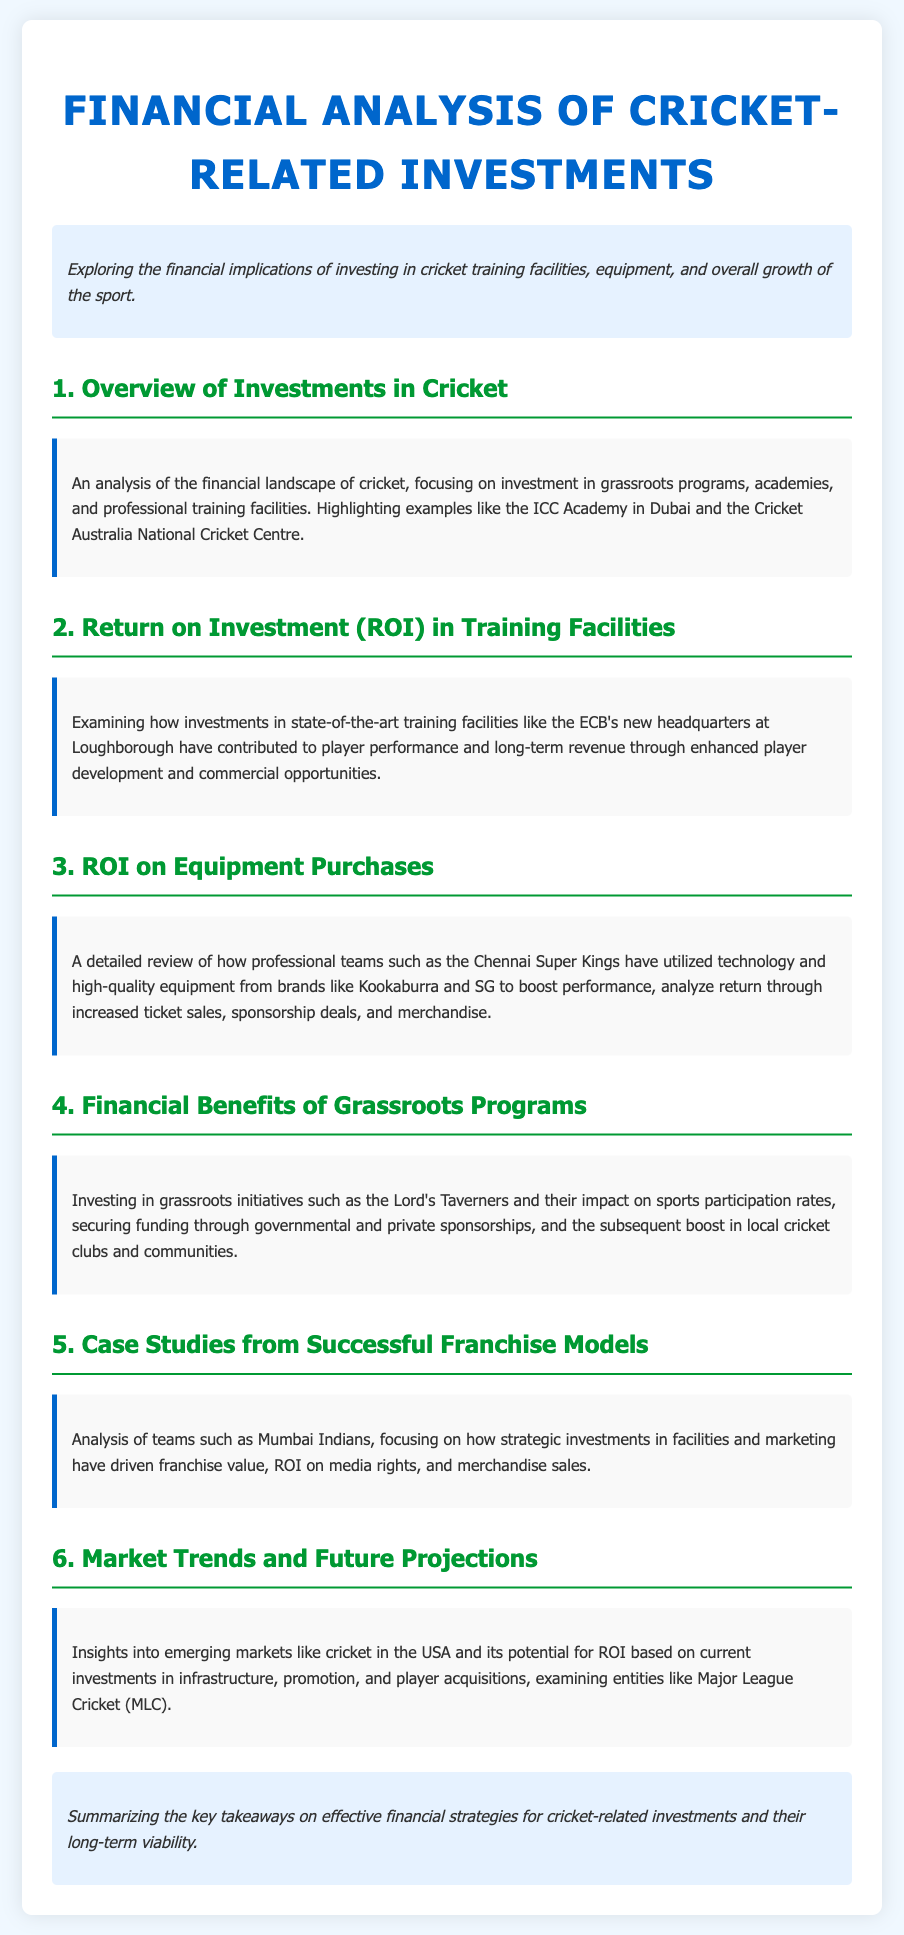What is the focus of the financial analysis? The focus is on investing in cricket training facilities, equipment, and overall growth of the sport.
Answer: Investing in cricket training facilities What does ROI stand for? ROI stands for Return on Investment, examining the profitability of investments made.
Answer: Return on Investment Which cricket academy is mentioned in the overview? The ICC Academy in Dubai is highlighted in the analysis.
Answer: ICC Academy in Dubai Which team is mentioned for utilizing technology and high-quality equipment? The Chennai Super Kings are mentioned in the context of improved performance through technology.
Answer: Chennai Super Kings What grassroots initiative is referenced in the document? The Lord's Taverners is mentioned concerning grassroots sports participation.
Answer: Lord's Taverners Which franchise model is analyzed for its success? The document analyzes the Mumbai Indians along with investment strategies.
Answer: Mumbai Indians What emerging market is discussed for future projections? Cricket in the USA is identified as an emerging market for potential ROI.
Answer: USA What is the conclusion's main theme? The conclusion summarizes effective financial strategies for cricket-related investments.
Answer: Effective financial strategies 